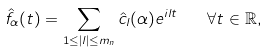<formula> <loc_0><loc_0><loc_500><loc_500>\hat { f } _ { \alpha } ( t ) = \sum _ { 1 \leq | l | \leq m _ { n } } \hat { c } _ { l } ( \alpha ) e ^ { i l t } \quad \forall t \in \mathbb { R } ,</formula> 